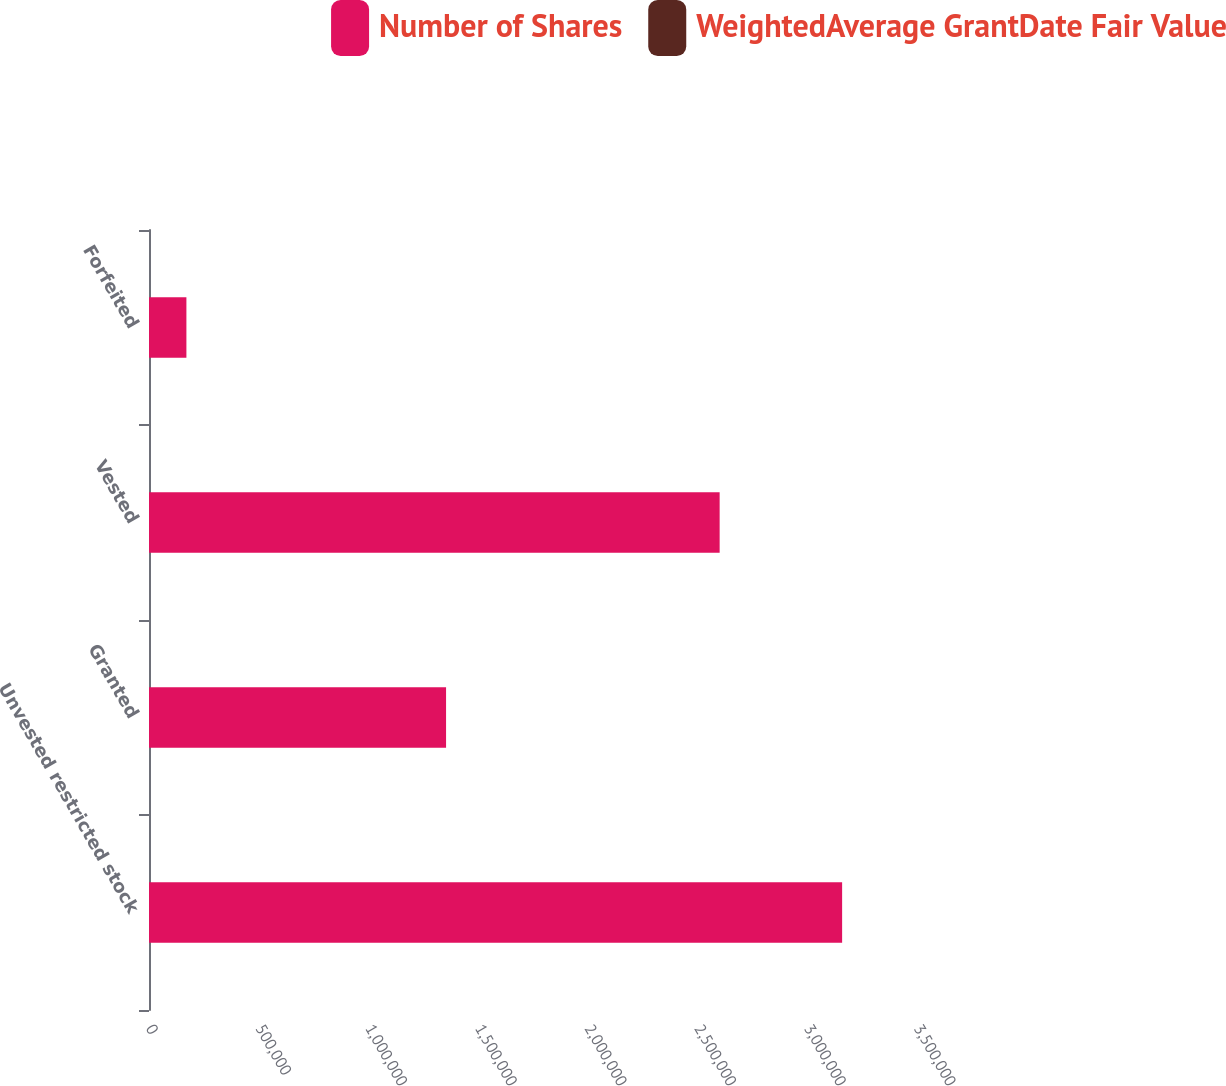Convert chart to OTSL. <chart><loc_0><loc_0><loc_500><loc_500><stacked_bar_chart><ecel><fcel>Unvested restricted stock<fcel>Granted<fcel>Vested<fcel>Forfeited<nl><fcel>Number of Shares<fcel>3.15872e+06<fcel>1.3538e+06<fcel>2.60056e+06<fcel>170424<nl><fcel>WeightedAverage GrantDate Fair Value<fcel>16.41<fcel>15.08<fcel>17.93<fcel>15.65<nl></chart> 